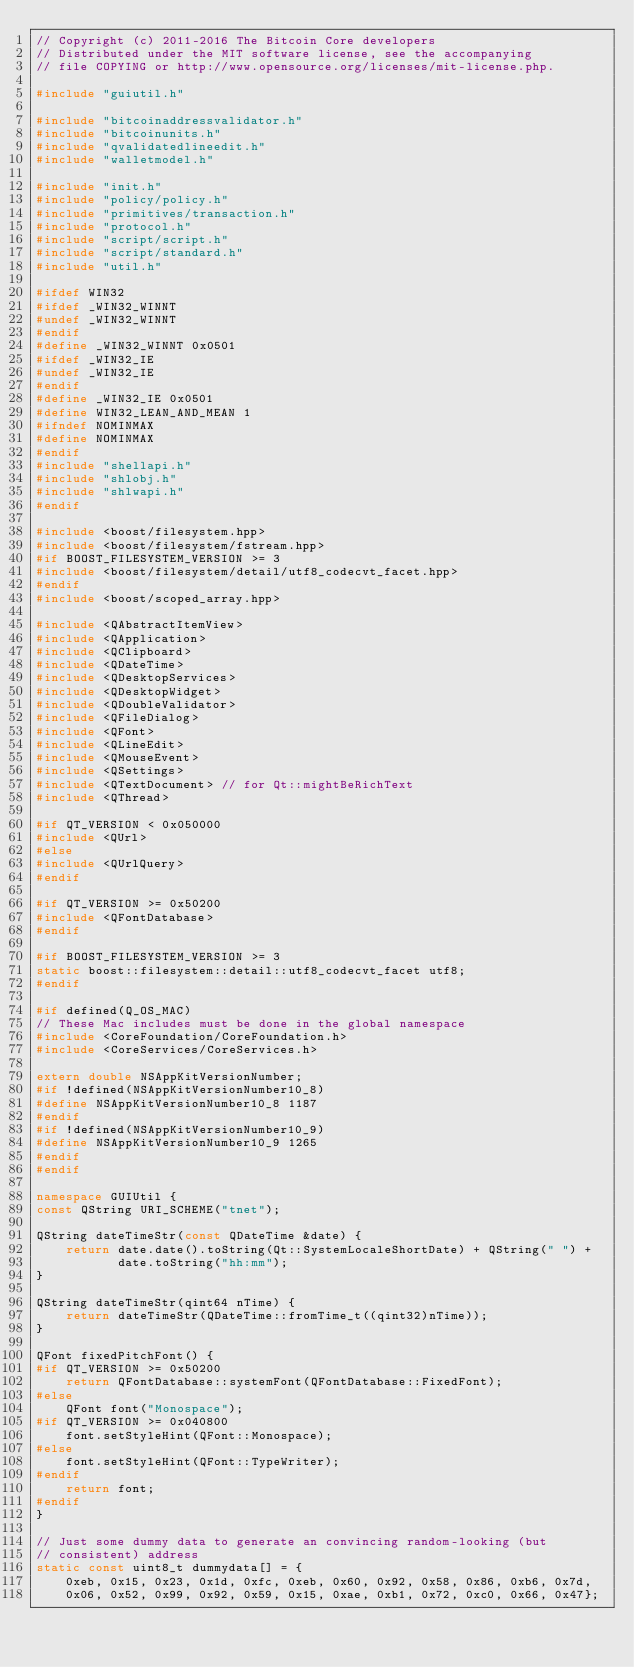<code> <loc_0><loc_0><loc_500><loc_500><_C++_>// Copyright (c) 2011-2016 The Bitcoin Core developers
// Distributed under the MIT software license, see the accompanying
// file COPYING or http://www.opensource.org/licenses/mit-license.php.

#include "guiutil.h"

#include "bitcoinaddressvalidator.h"
#include "bitcoinunits.h"
#include "qvalidatedlineedit.h"
#include "walletmodel.h"

#include "init.h"
#include "policy/policy.h"
#include "primitives/transaction.h"
#include "protocol.h"
#include "script/script.h"
#include "script/standard.h"
#include "util.h"

#ifdef WIN32
#ifdef _WIN32_WINNT
#undef _WIN32_WINNT
#endif
#define _WIN32_WINNT 0x0501
#ifdef _WIN32_IE
#undef _WIN32_IE
#endif
#define _WIN32_IE 0x0501
#define WIN32_LEAN_AND_MEAN 1
#ifndef NOMINMAX
#define NOMINMAX
#endif
#include "shellapi.h"
#include "shlobj.h"
#include "shlwapi.h"
#endif

#include <boost/filesystem.hpp>
#include <boost/filesystem/fstream.hpp>
#if BOOST_FILESYSTEM_VERSION >= 3
#include <boost/filesystem/detail/utf8_codecvt_facet.hpp>
#endif
#include <boost/scoped_array.hpp>

#include <QAbstractItemView>
#include <QApplication>
#include <QClipboard>
#include <QDateTime>
#include <QDesktopServices>
#include <QDesktopWidget>
#include <QDoubleValidator>
#include <QFileDialog>
#include <QFont>
#include <QLineEdit>
#include <QMouseEvent>
#include <QSettings>
#include <QTextDocument> // for Qt::mightBeRichText
#include <QThread>

#if QT_VERSION < 0x050000
#include <QUrl>
#else
#include <QUrlQuery>
#endif

#if QT_VERSION >= 0x50200
#include <QFontDatabase>
#endif

#if BOOST_FILESYSTEM_VERSION >= 3
static boost::filesystem::detail::utf8_codecvt_facet utf8;
#endif

#if defined(Q_OS_MAC)
// These Mac includes must be done in the global namespace
#include <CoreFoundation/CoreFoundation.h>
#include <CoreServices/CoreServices.h>

extern double NSAppKitVersionNumber;
#if !defined(NSAppKitVersionNumber10_8)
#define NSAppKitVersionNumber10_8 1187
#endif
#if !defined(NSAppKitVersionNumber10_9)
#define NSAppKitVersionNumber10_9 1265
#endif
#endif

namespace GUIUtil {
const QString URI_SCHEME("tnet");

QString dateTimeStr(const QDateTime &date) {
    return date.date().toString(Qt::SystemLocaleShortDate) + QString(" ") +
           date.toString("hh:mm");
}

QString dateTimeStr(qint64 nTime) {
    return dateTimeStr(QDateTime::fromTime_t((qint32)nTime));
}

QFont fixedPitchFont() {
#if QT_VERSION >= 0x50200
    return QFontDatabase::systemFont(QFontDatabase::FixedFont);
#else
    QFont font("Monospace");
#if QT_VERSION >= 0x040800
    font.setStyleHint(QFont::Monospace);
#else
    font.setStyleHint(QFont::TypeWriter);
#endif
    return font;
#endif
}

// Just some dummy data to generate an convincing random-looking (but
// consistent) address
static const uint8_t dummydata[] = {
    0xeb, 0x15, 0x23, 0x1d, 0xfc, 0xeb, 0x60, 0x92, 0x58, 0x86, 0xb6, 0x7d,
    0x06, 0x52, 0x99, 0x92, 0x59, 0x15, 0xae, 0xb1, 0x72, 0xc0, 0x66, 0x47};
</code> 